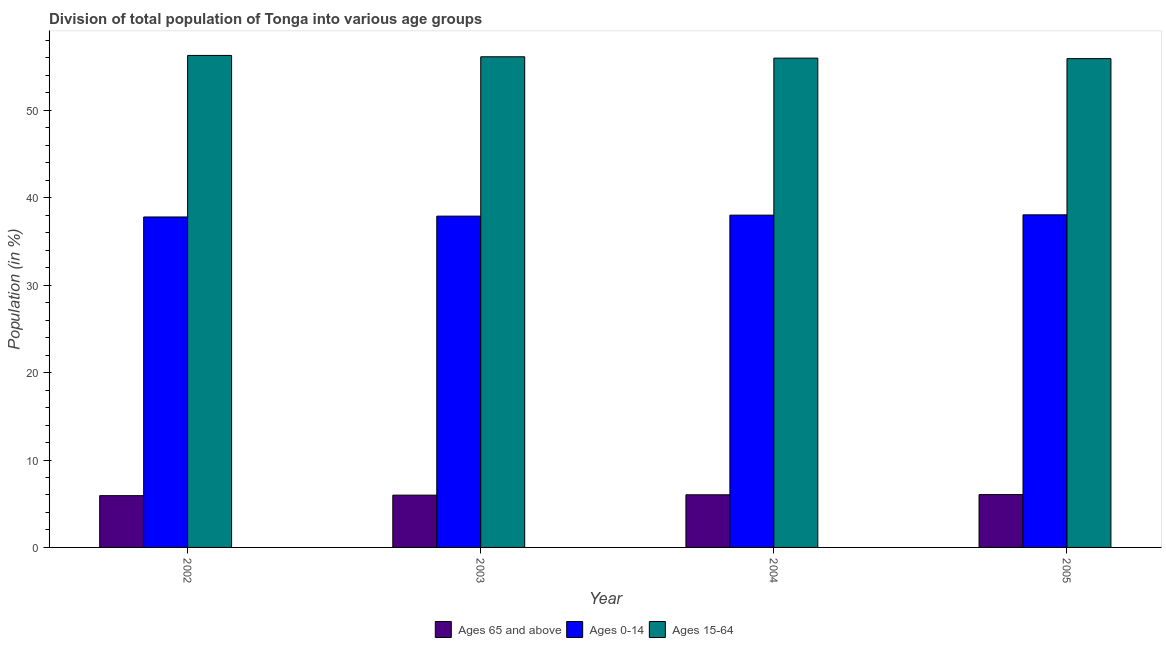What is the percentage of population within the age-group 0-14 in 2004?
Your answer should be very brief. 38.01. Across all years, what is the maximum percentage of population within the age-group of 65 and above?
Give a very brief answer. 6.04. Across all years, what is the minimum percentage of population within the age-group 15-64?
Make the answer very short. 55.91. In which year was the percentage of population within the age-group 0-14 maximum?
Offer a terse response. 2005. In which year was the percentage of population within the age-group of 65 and above minimum?
Give a very brief answer. 2002. What is the total percentage of population within the age-group 0-14 in the graph?
Ensure brevity in your answer.  151.75. What is the difference between the percentage of population within the age-group of 65 and above in 2003 and that in 2005?
Offer a terse response. -0.06. What is the difference between the percentage of population within the age-group 15-64 in 2002 and the percentage of population within the age-group 0-14 in 2004?
Offer a very short reply. 0.31. What is the average percentage of population within the age-group of 65 and above per year?
Your response must be concise. 5.99. In how many years, is the percentage of population within the age-group of 65 and above greater than 10 %?
Give a very brief answer. 0. What is the ratio of the percentage of population within the age-group of 65 and above in 2003 to that in 2005?
Keep it short and to the point. 0.99. Is the difference between the percentage of population within the age-group of 65 and above in 2002 and 2003 greater than the difference between the percentage of population within the age-group 15-64 in 2002 and 2003?
Make the answer very short. No. What is the difference between the highest and the second highest percentage of population within the age-group 0-14?
Your answer should be very brief. 0.03. What is the difference between the highest and the lowest percentage of population within the age-group of 65 and above?
Make the answer very short. 0.12. What does the 2nd bar from the left in 2003 represents?
Offer a very short reply. Ages 0-14. What does the 3rd bar from the right in 2002 represents?
Ensure brevity in your answer.  Ages 65 and above. Is it the case that in every year, the sum of the percentage of population within the age-group of 65 and above and percentage of population within the age-group 0-14 is greater than the percentage of population within the age-group 15-64?
Offer a very short reply. No. How many bars are there?
Ensure brevity in your answer.  12. How many years are there in the graph?
Provide a succinct answer. 4. Where does the legend appear in the graph?
Give a very brief answer. Bottom center. How many legend labels are there?
Ensure brevity in your answer.  3. How are the legend labels stacked?
Provide a short and direct response. Horizontal. What is the title of the graph?
Offer a terse response. Division of total population of Tonga into various age groups
. Does "Ages 20-60" appear as one of the legend labels in the graph?
Your answer should be compact. No. What is the label or title of the X-axis?
Your answer should be very brief. Year. What is the Population (in %) in Ages 65 and above in 2002?
Your answer should be compact. 5.92. What is the Population (in %) in Ages 0-14 in 2002?
Provide a short and direct response. 37.8. What is the Population (in %) of Ages 15-64 in 2002?
Give a very brief answer. 56.28. What is the Population (in %) in Ages 65 and above in 2003?
Offer a very short reply. 5.98. What is the Population (in %) of Ages 0-14 in 2003?
Your answer should be very brief. 37.9. What is the Population (in %) of Ages 15-64 in 2003?
Keep it short and to the point. 56.12. What is the Population (in %) in Ages 65 and above in 2004?
Provide a succinct answer. 6.02. What is the Population (in %) in Ages 0-14 in 2004?
Your response must be concise. 38.01. What is the Population (in %) in Ages 15-64 in 2004?
Provide a short and direct response. 55.97. What is the Population (in %) of Ages 65 and above in 2005?
Your answer should be very brief. 6.04. What is the Population (in %) of Ages 0-14 in 2005?
Ensure brevity in your answer.  38.04. What is the Population (in %) of Ages 15-64 in 2005?
Keep it short and to the point. 55.91. Across all years, what is the maximum Population (in %) in Ages 65 and above?
Provide a short and direct response. 6.04. Across all years, what is the maximum Population (in %) of Ages 0-14?
Keep it short and to the point. 38.04. Across all years, what is the maximum Population (in %) in Ages 15-64?
Provide a succinct answer. 56.28. Across all years, what is the minimum Population (in %) of Ages 65 and above?
Your response must be concise. 5.92. Across all years, what is the minimum Population (in %) of Ages 0-14?
Your answer should be compact. 37.8. Across all years, what is the minimum Population (in %) of Ages 15-64?
Your answer should be compact. 55.91. What is the total Population (in %) of Ages 65 and above in the graph?
Make the answer very short. 23.97. What is the total Population (in %) of Ages 0-14 in the graph?
Ensure brevity in your answer.  151.75. What is the total Population (in %) in Ages 15-64 in the graph?
Ensure brevity in your answer.  224.28. What is the difference between the Population (in %) of Ages 65 and above in 2002 and that in 2003?
Your answer should be compact. -0.06. What is the difference between the Population (in %) in Ages 0-14 in 2002 and that in 2003?
Your response must be concise. -0.1. What is the difference between the Population (in %) in Ages 15-64 in 2002 and that in 2003?
Keep it short and to the point. 0.15. What is the difference between the Population (in %) of Ages 65 and above in 2002 and that in 2004?
Ensure brevity in your answer.  -0.1. What is the difference between the Population (in %) of Ages 0-14 in 2002 and that in 2004?
Your response must be concise. -0.21. What is the difference between the Population (in %) in Ages 15-64 in 2002 and that in 2004?
Give a very brief answer. 0.31. What is the difference between the Population (in %) of Ages 65 and above in 2002 and that in 2005?
Your answer should be compact. -0.12. What is the difference between the Population (in %) in Ages 0-14 in 2002 and that in 2005?
Keep it short and to the point. -0.24. What is the difference between the Population (in %) of Ages 15-64 in 2002 and that in 2005?
Your answer should be very brief. 0.36. What is the difference between the Population (in %) in Ages 65 and above in 2003 and that in 2004?
Provide a succinct answer. -0.04. What is the difference between the Population (in %) of Ages 0-14 in 2003 and that in 2004?
Your answer should be very brief. -0.11. What is the difference between the Population (in %) in Ages 15-64 in 2003 and that in 2004?
Provide a succinct answer. 0.15. What is the difference between the Population (in %) in Ages 65 and above in 2003 and that in 2005?
Keep it short and to the point. -0.06. What is the difference between the Population (in %) in Ages 0-14 in 2003 and that in 2005?
Provide a succinct answer. -0.15. What is the difference between the Population (in %) in Ages 15-64 in 2003 and that in 2005?
Make the answer very short. 0.21. What is the difference between the Population (in %) of Ages 65 and above in 2004 and that in 2005?
Your answer should be very brief. -0.02. What is the difference between the Population (in %) of Ages 0-14 in 2004 and that in 2005?
Your answer should be compact. -0.03. What is the difference between the Population (in %) of Ages 15-64 in 2004 and that in 2005?
Keep it short and to the point. 0.06. What is the difference between the Population (in %) in Ages 65 and above in 2002 and the Population (in %) in Ages 0-14 in 2003?
Your answer should be very brief. -31.97. What is the difference between the Population (in %) in Ages 65 and above in 2002 and the Population (in %) in Ages 15-64 in 2003?
Offer a very short reply. -50.2. What is the difference between the Population (in %) of Ages 0-14 in 2002 and the Population (in %) of Ages 15-64 in 2003?
Your answer should be very brief. -18.32. What is the difference between the Population (in %) of Ages 65 and above in 2002 and the Population (in %) of Ages 0-14 in 2004?
Ensure brevity in your answer.  -32.09. What is the difference between the Population (in %) in Ages 65 and above in 2002 and the Population (in %) in Ages 15-64 in 2004?
Your response must be concise. -50.05. What is the difference between the Population (in %) of Ages 0-14 in 2002 and the Population (in %) of Ages 15-64 in 2004?
Give a very brief answer. -18.17. What is the difference between the Population (in %) in Ages 65 and above in 2002 and the Population (in %) in Ages 0-14 in 2005?
Your answer should be compact. -32.12. What is the difference between the Population (in %) in Ages 65 and above in 2002 and the Population (in %) in Ages 15-64 in 2005?
Ensure brevity in your answer.  -49.99. What is the difference between the Population (in %) of Ages 0-14 in 2002 and the Population (in %) of Ages 15-64 in 2005?
Make the answer very short. -18.11. What is the difference between the Population (in %) in Ages 65 and above in 2003 and the Population (in %) in Ages 0-14 in 2004?
Give a very brief answer. -32.03. What is the difference between the Population (in %) of Ages 65 and above in 2003 and the Population (in %) of Ages 15-64 in 2004?
Keep it short and to the point. -49.99. What is the difference between the Population (in %) in Ages 0-14 in 2003 and the Population (in %) in Ages 15-64 in 2004?
Keep it short and to the point. -18.07. What is the difference between the Population (in %) in Ages 65 and above in 2003 and the Population (in %) in Ages 0-14 in 2005?
Make the answer very short. -32.06. What is the difference between the Population (in %) of Ages 65 and above in 2003 and the Population (in %) of Ages 15-64 in 2005?
Your response must be concise. -49.93. What is the difference between the Population (in %) of Ages 0-14 in 2003 and the Population (in %) of Ages 15-64 in 2005?
Offer a very short reply. -18.02. What is the difference between the Population (in %) of Ages 65 and above in 2004 and the Population (in %) of Ages 0-14 in 2005?
Make the answer very short. -32.02. What is the difference between the Population (in %) in Ages 65 and above in 2004 and the Population (in %) in Ages 15-64 in 2005?
Keep it short and to the point. -49.89. What is the difference between the Population (in %) in Ages 0-14 in 2004 and the Population (in %) in Ages 15-64 in 2005?
Your response must be concise. -17.9. What is the average Population (in %) in Ages 65 and above per year?
Provide a short and direct response. 5.99. What is the average Population (in %) of Ages 0-14 per year?
Keep it short and to the point. 37.94. What is the average Population (in %) in Ages 15-64 per year?
Provide a short and direct response. 56.07. In the year 2002, what is the difference between the Population (in %) of Ages 65 and above and Population (in %) of Ages 0-14?
Make the answer very short. -31.88. In the year 2002, what is the difference between the Population (in %) of Ages 65 and above and Population (in %) of Ages 15-64?
Give a very brief answer. -50.35. In the year 2002, what is the difference between the Population (in %) in Ages 0-14 and Population (in %) in Ages 15-64?
Keep it short and to the point. -18.48. In the year 2003, what is the difference between the Population (in %) in Ages 65 and above and Population (in %) in Ages 0-14?
Offer a terse response. -31.91. In the year 2003, what is the difference between the Population (in %) of Ages 65 and above and Population (in %) of Ages 15-64?
Your answer should be compact. -50.14. In the year 2003, what is the difference between the Population (in %) in Ages 0-14 and Population (in %) in Ages 15-64?
Offer a very short reply. -18.23. In the year 2004, what is the difference between the Population (in %) in Ages 65 and above and Population (in %) in Ages 0-14?
Make the answer very short. -31.99. In the year 2004, what is the difference between the Population (in %) of Ages 65 and above and Population (in %) of Ages 15-64?
Keep it short and to the point. -49.95. In the year 2004, what is the difference between the Population (in %) of Ages 0-14 and Population (in %) of Ages 15-64?
Offer a terse response. -17.96. In the year 2005, what is the difference between the Population (in %) of Ages 65 and above and Population (in %) of Ages 0-14?
Give a very brief answer. -32. In the year 2005, what is the difference between the Population (in %) of Ages 65 and above and Population (in %) of Ages 15-64?
Provide a succinct answer. -49.87. In the year 2005, what is the difference between the Population (in %) in Ages 0-14 and Population (in %) in Ages 15-64?
Your response must be concise. -17.87. What is the ratio of the Population (in %) in Ages 65 and above in 2002 to that in 2003?
Your answer should be very brief. 0.99. What is the ratio of the Population (in %) of Ages 15-64 in 2002 to that in 2003?
Offer a very short reply. 1. What is the ratio of the Population (in %) of Ages 65 and above in 2002 to that in 2004?
Your answer should be very brief. 0.98. What is the ratio of the Population (in %) in Ages 65 and above in 2002 to that in 2005?
Offer a very short reply. 0.98. What is the ratio of the Population (in %) of Ages 15-64 in 2002 to that in 2005?
Your answer should be very brief. 1.01. What is the ratio of the Population (in %) of Ages 15-64 in 2003 to that in 2004?
Your response must be concise. 1. What is the ratio of the Population (in %) in Ages 0-14 in 2003 to that in 2005?
Ensure brevity in your answer.  1. What is the ratio of the Population (in %) in Ages 65 and above in 2004 to that in 2005?
Offer a very short reply. 1. What is the ratio of the Population (in %) of Ages 15-64 in 2004 to that in 2005?
Give a very brief answer. 1. What is the difference between the highest and the second highest Population (in %) in Ages 65 and above?
Your response must be concise. 0.02. What is the difference between the highest and the second highest Population (in %) in Ages 0-14?
Make the answer very short. 0.03. What is the difference between the highest and the second highest Population (in %) in Ages 15-64?
Offer a terse response. 0.15. What is the difference between the highest and the lowest Population (in %) in Ages 65 and above?
Your answer should be compact. 0.12. What is the difference between the highest and the lowest Population (in %) of Ages 0-14?
Provide a short and direct response. 0.24. What is the difference between the highest and the lowest Population (in %) in Ages 15-64?
Your answer should be very brief. 0.36. 